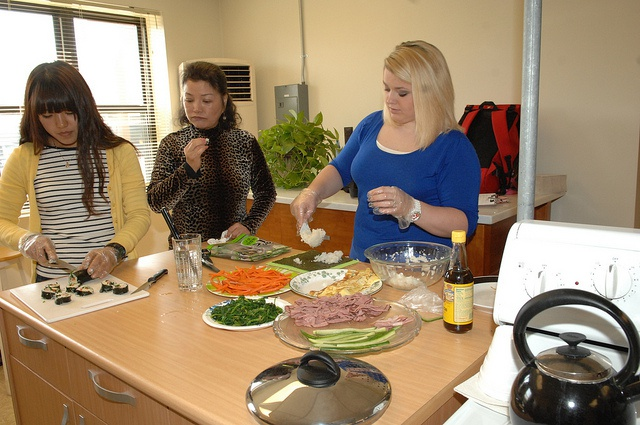Describe the objects in this image and their specific colors. I can see people in gray, black, tan, and darkgray tones, people in gray, navy, and tan tones, oven in gray, white, and darkgray tones, people in gray, black, olive, and maroon tones, and potted plant in gray, olive, black, tan, and darkgreen tones in this image. 